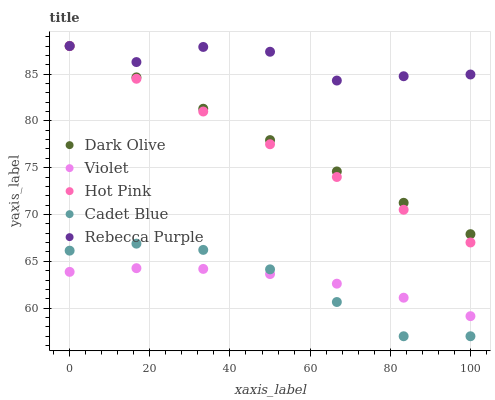Does Cadet Blue have the minimum area under the curve?
Answer yes or no. Yes. Does Rebecca Purple have the maximum area under the curve?
Answer yes or no. Yes. Does Hot Pink have the minimum area under the curve?
Answer yes or no. No. Does Hot Pink have the maximum area under the curve?
Answer yes or no. No. Is Dark Olive the smoothest?
Answer yes or no. Yes. Is Rebecca Purple the roughest?
Answer yes or no. Yes. Is Hot Pink the smoothest?
Answer yes or no. No. Is Hot Pink the roughest?
Answer yes or no. No. Does Cadet Blue have the lowest value?
Answer yes or no. Yes. Does Hot Pink have the lowest value?
Answer yes or no. No. Does Rebecca Purple have the highest value?
Answer yes or no. Yes. Does Violet have the highest value?
Answer yes or no. No. Is Violet less than Rebecca Purple?
Answer yes or no. Yes. Is Rebecca Purple greater than Violet?
Answer yes or no. Yes. Does Rebecca Purple intersect Hot Pink?
Answer yes or no. Yes. Is Rebecca Purple less than Hot Pink?
Answer yes or no. No. Is Rebecca Purple greater than Hot Pink?
Answer yes or no. No. Does Violet intersect Rebecca Purple?
Answer yes or no. No. 